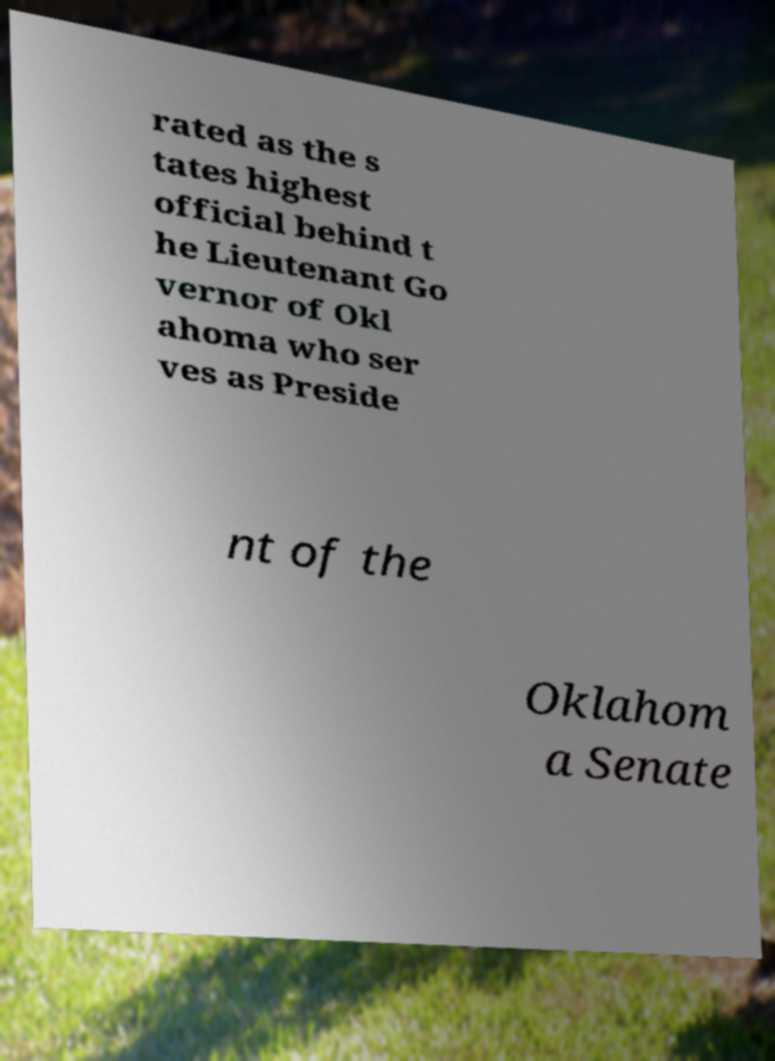For documentation purposes, I need the text within this image transcribed. Could you provide that? rated as the s tates highest official behind t he Lieutenant Go vernor of Okl ahoma who ser ves as Preside nt of the Oklahom a Senate 